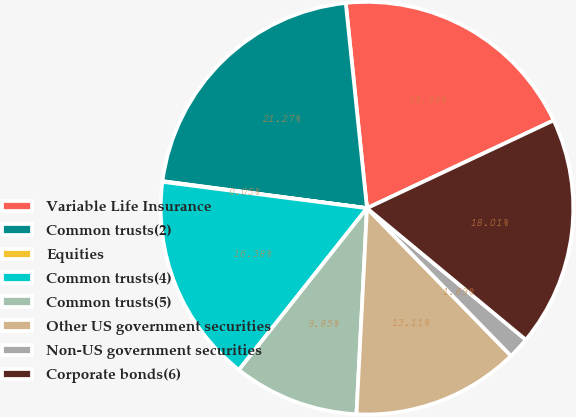Convert chart to OTSL. <chart><loc_0><loc_0><loc_500><loc_500><pie_chart><fcel>Variable Life Insurance<fcel>Common trusts(2)<fcel>Equities<fcel>Common trusts(4)<fcel>Common trusts(5)<fcel>Other US government securities<fcel>Non-US government securities<fcel>Corporate bonds(6)<nl><fcel>19.64%<fcel>21.27%<fcel>0.05%<fcel>16.38%<fcel>9.85%<fcel>13.11%<fcel>1.69%<fcel>18.01%<nl></chart> 